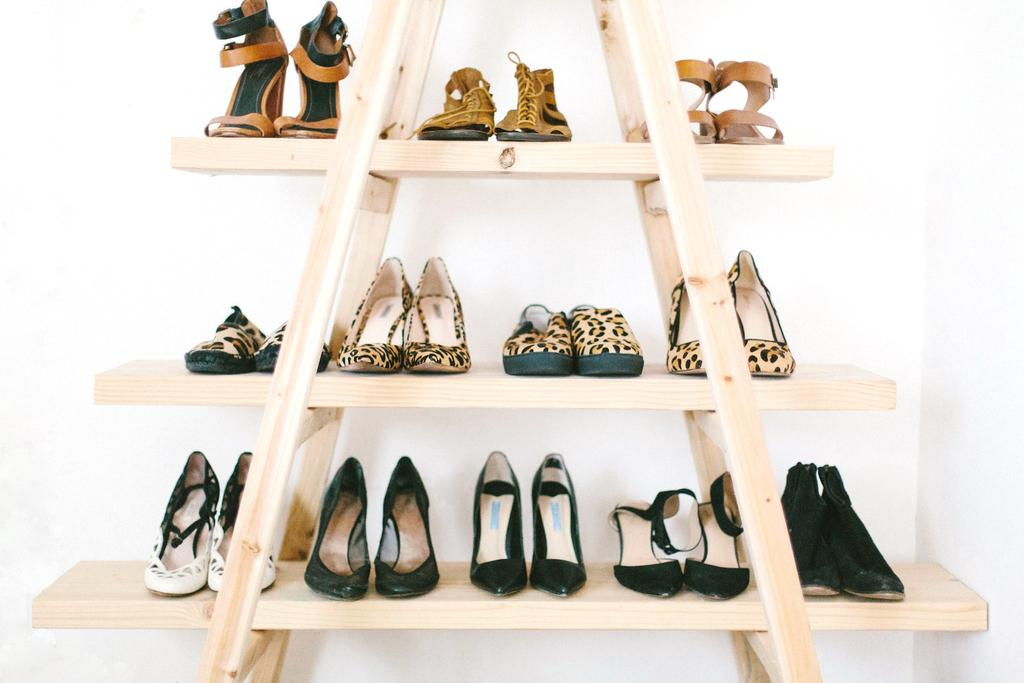What type of footwear is visible in the image? There are pairs of heels in the image. How are the heels arranged in the image? The heels are on racks in the image. What can be seen in the background of the image? There is a wall in the background of the image. What type of respect can be seen in the image? There is no indication of respect in the image, as it features pairs of heels on racks and a wall in the background. 